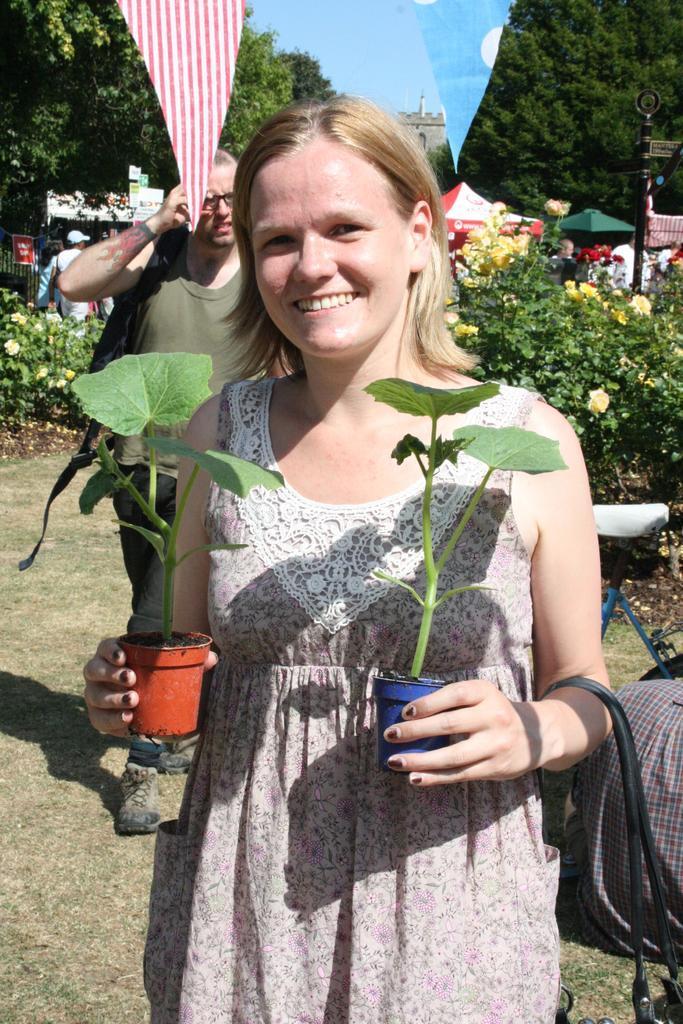Describe this image in one or two sentences. In the foreground I can see a woman is holding two houseplants in her hand. In the background I can see plants, crowd and tents on the road. On the top I can see trees and the sky. This image is taken during a day in the garden. 